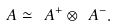<formula> <loc_0><loc_0><loc_500><loc_500>\ A \simeq \ A ^ { + } \otimes \ A ^ { - } .</formula> 